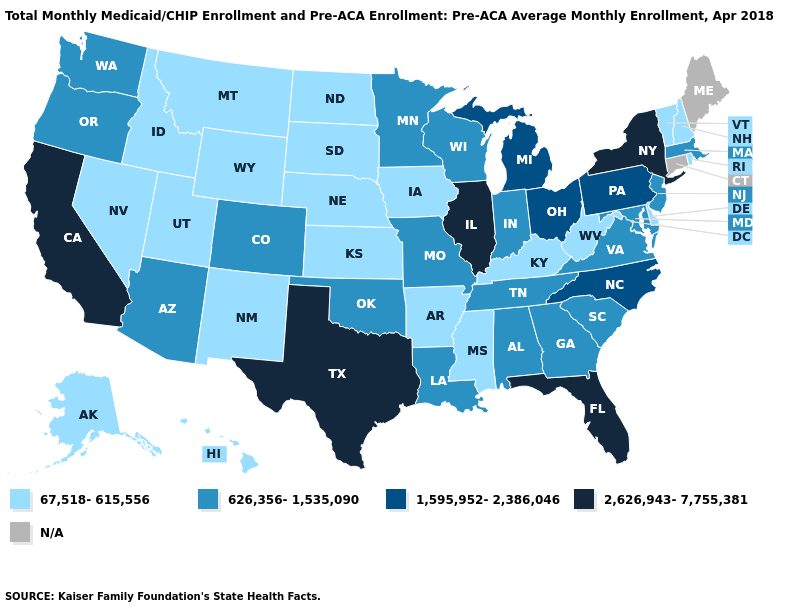Among the states that border Arkansas , which have the highest value?
Answer briefly. Texas. Name the states that have a value in the range 626,356-1,535,090?
Keep it brief. Alabama, Arizona, Colorado, Georgia, Indiana, Louisiana, Maryland, Massachusetts, Minnesota, Missouri, New Jersey, Oklahoma, Oregon, South Carolina, Tennessee, Virginia, Washington, Wisconsin. What is the value of Pennsylvania?
Be succinct. 1,595,952-2,386,046. Among the states that border Kentucky , which have the highest value?
Answer briefly. Illinois. What is the value of Maryland?
Keep it brief. 626,356-1,535,090. What is the value of Mississippi?
Be succinct. 67,518-615,556. Among the states that border New Hampshire , which have the lowest value?
Be succinct. Vermont. Does New York have the lowest value in the Northeast?
Be succinct. No. Name the states that have a value in the range 2,626,943-7,755,381?
Answer briefly. California, Florida, Illinois, New York, Texas. Among the states that border North Carolina , which have the highest value?
Write a very short answer. Georgia, South Carolina, Tennessee, Virginia. What is the lowest value in states that border Arkansas?
Write a very short answer. 67,518-615,556. Among the states that border New Jersey , which have the lowest value?
Quick response, please. Delaware. What is the highest value in states that border Tennessee?
Write a very short answer. 1,595,952-2,386,046. What is the value of North Carolina?
Short answer required. 1,595,952-2,386,046. 